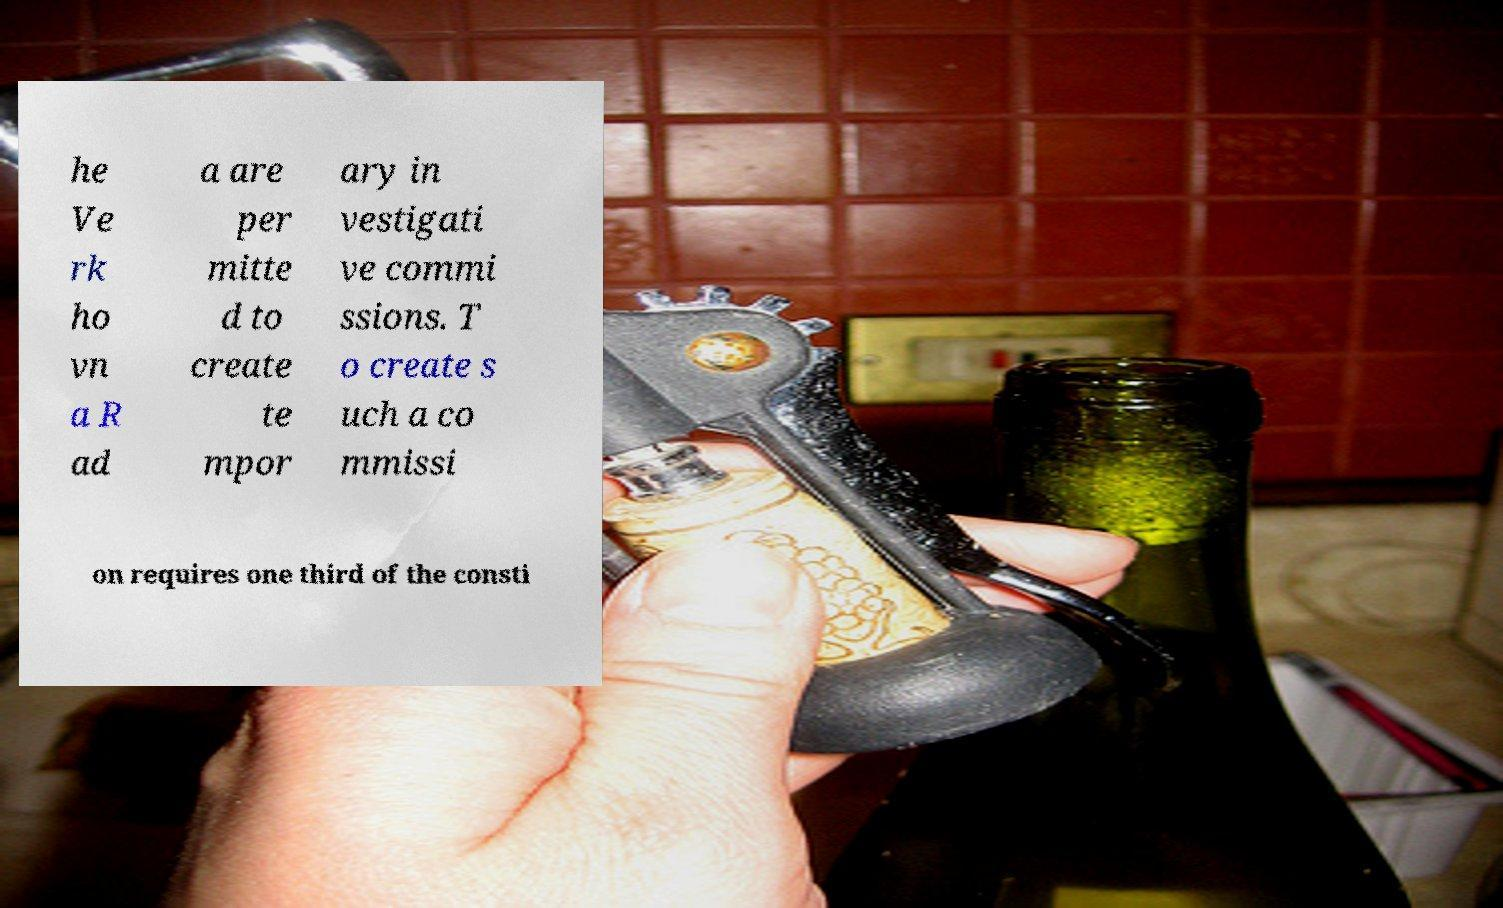Please read and relay the text visible in this image. What does it say? he Ve rk ho vn a R ad a are per mitte d to create te mpor ary in vestigati ve commi ssions. T o create s uch a co mmissi on requires one third of the consti 